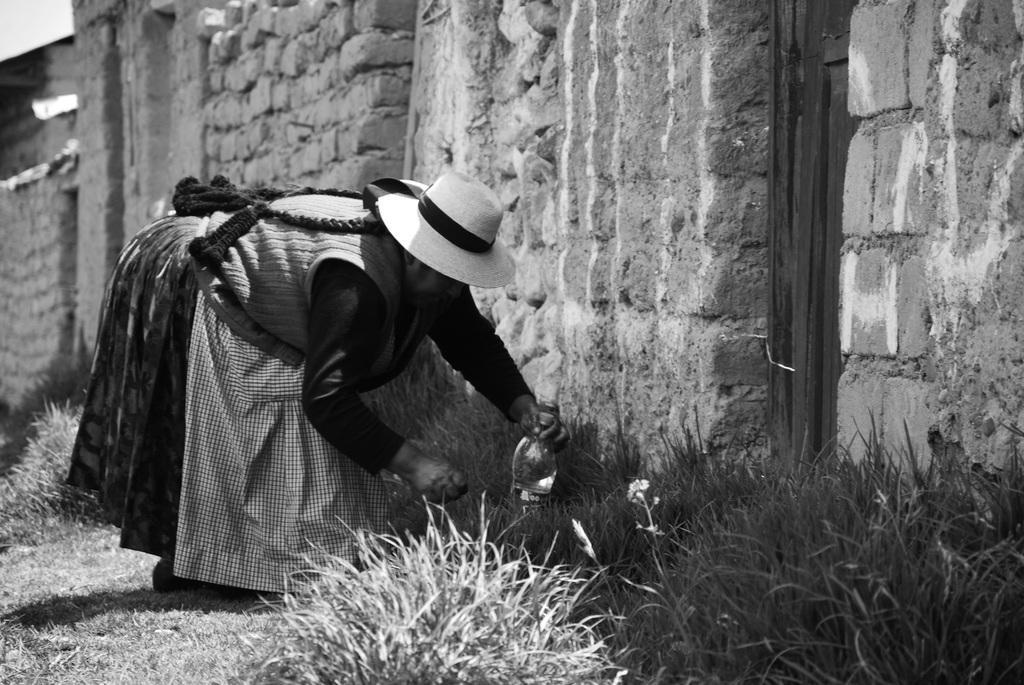Can you describe this image briefly? It is a black and white image, there is a woman doing some work with the object she is holding and in front of her there is a lot of grass, behind the grass there is a wall. 